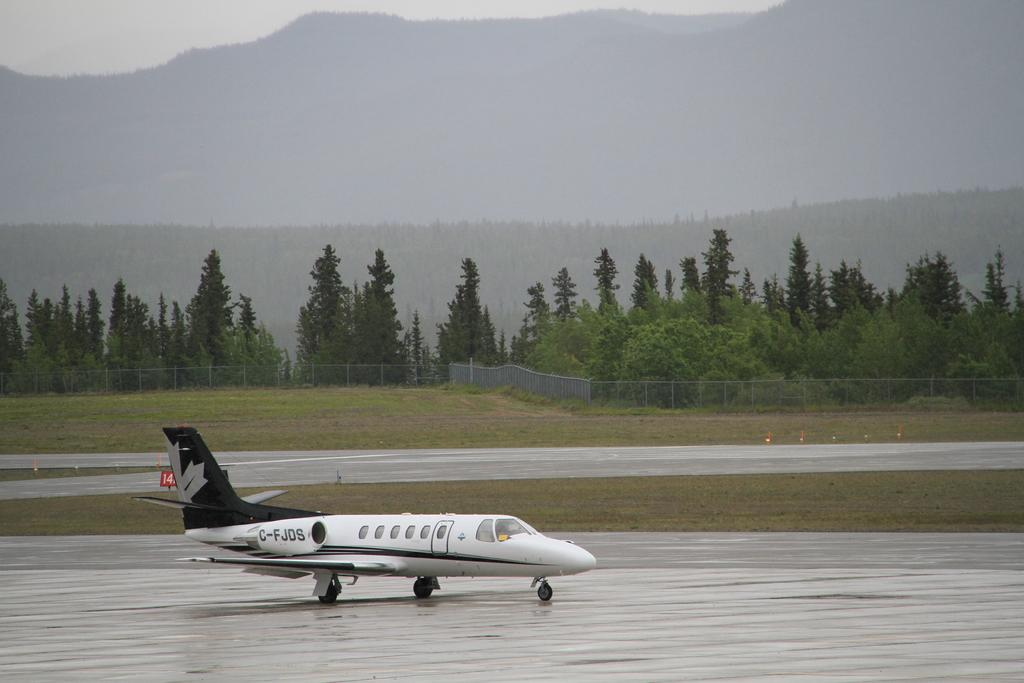What is the unusual object on the road in the image? There is an aeroplane on the road in the image. What type of vegetation can be seen in the image? There is grass visible in the image. What type of barrier is present in the image? There is a fence in the image. What type of natural feature is visible in the image? There are trees and a mountain in the image. What part of the natural environment is visible in the image? The sky is visible in the image. What type of quince is being exchanged between the trees in the image? There is no quince or exchange present in the image; it features an aeroplane on the road, grass, a fence, trees, a mountain, and the sky. 